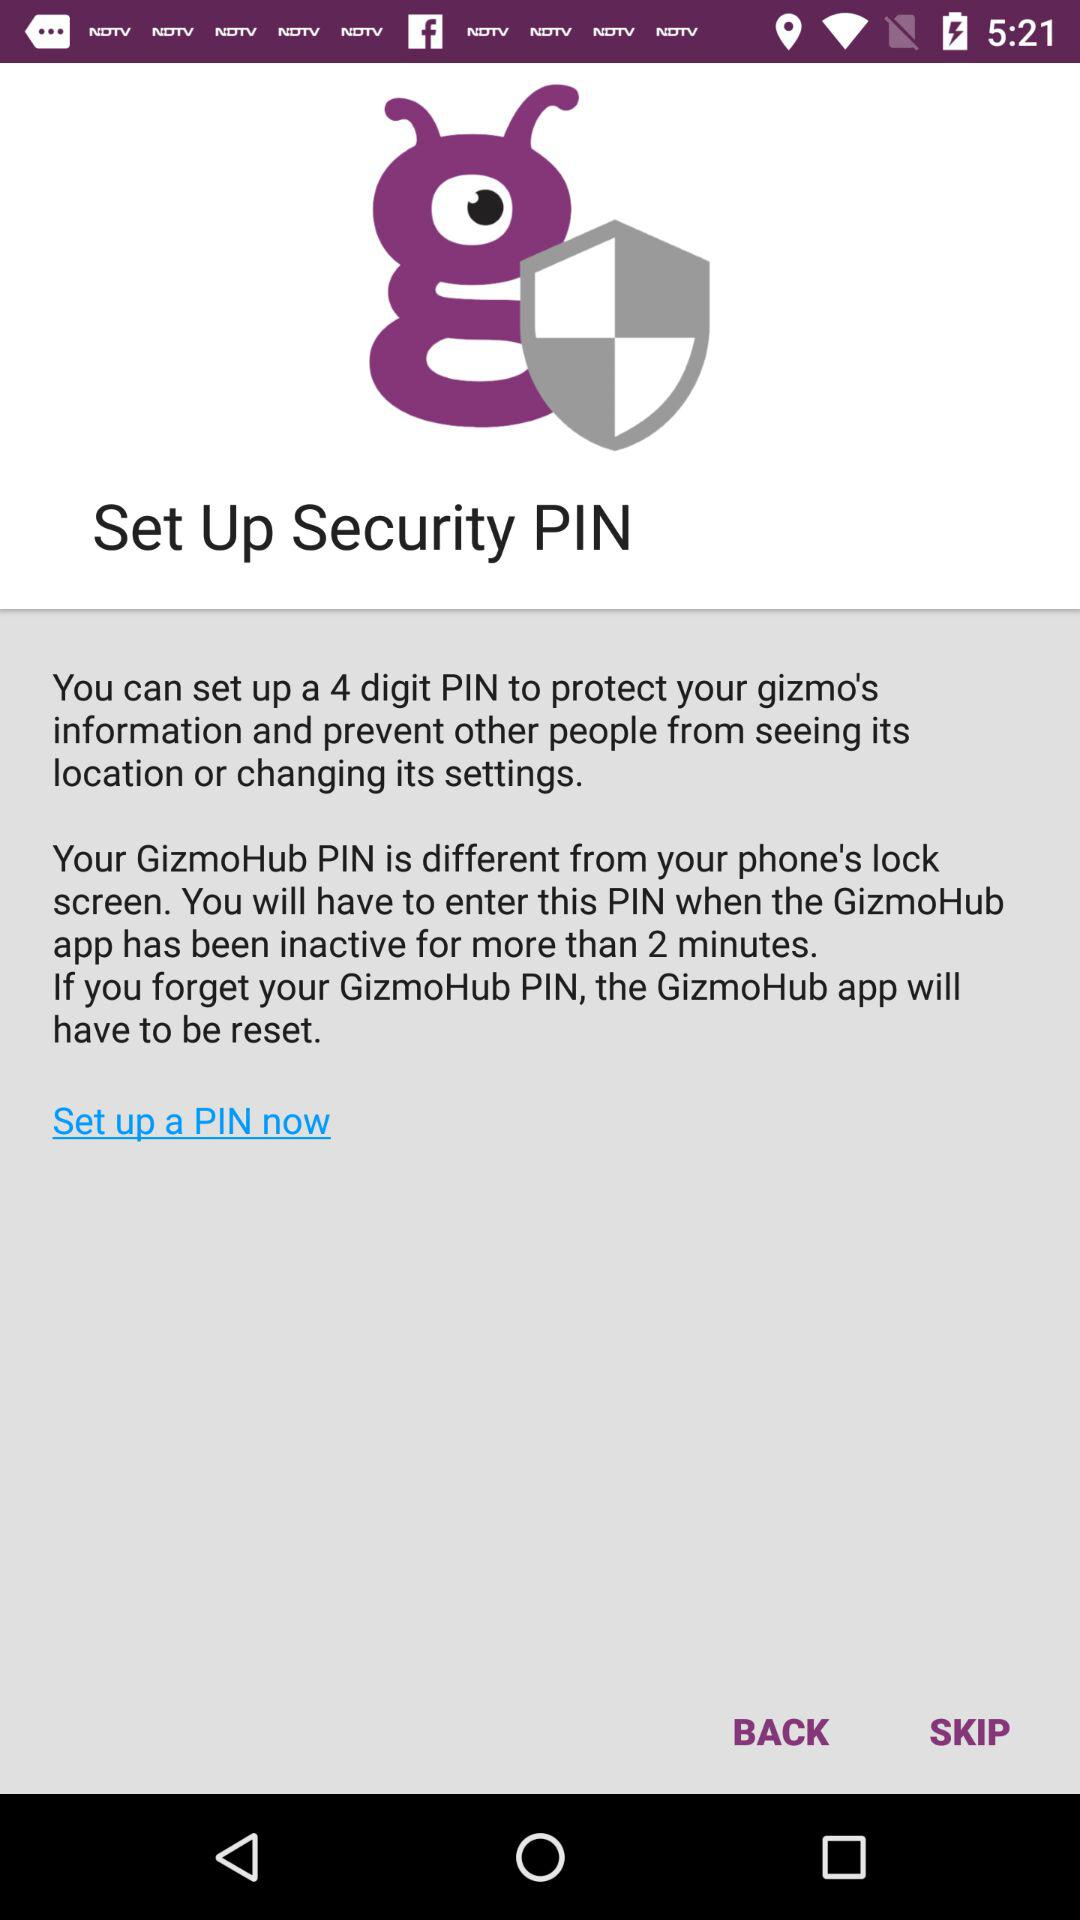How many digits should be in the PIN? The number of digits that should be in the PIN is 4. 